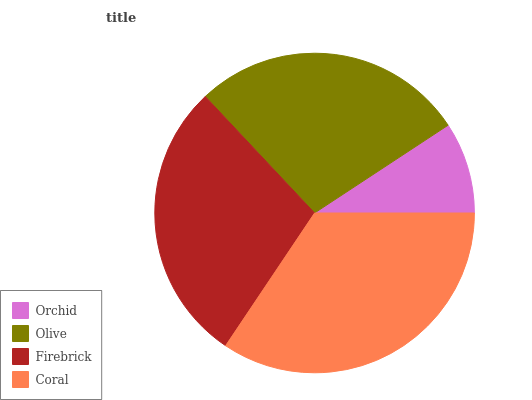Is Orchid the minimum?
Answer yes or no. Yes. Is Coral the maximum?
Answer yes or no. Yes. Is Olive the minimum?
Answer yes or no. No. Is Olive the maximum?
Answer yes or no. No. Is Olive greater than Orchid?
Answer yes or no. Yes. Is Orchid less than Olive?
Answer yes or no. Yes. Is Orchid greater than Olive?
Answer yes or no. No. Is Olive less than Orchid?
Answer yes or no. No. Is Firebrick the high median?
Answer yes or no. Yes. Is Olive the low median?
Answer yes or no. Yes. Is Orchid the high median?
Answer yes or no. No. Is Orchid the low median?
Answer yes or no. No. 